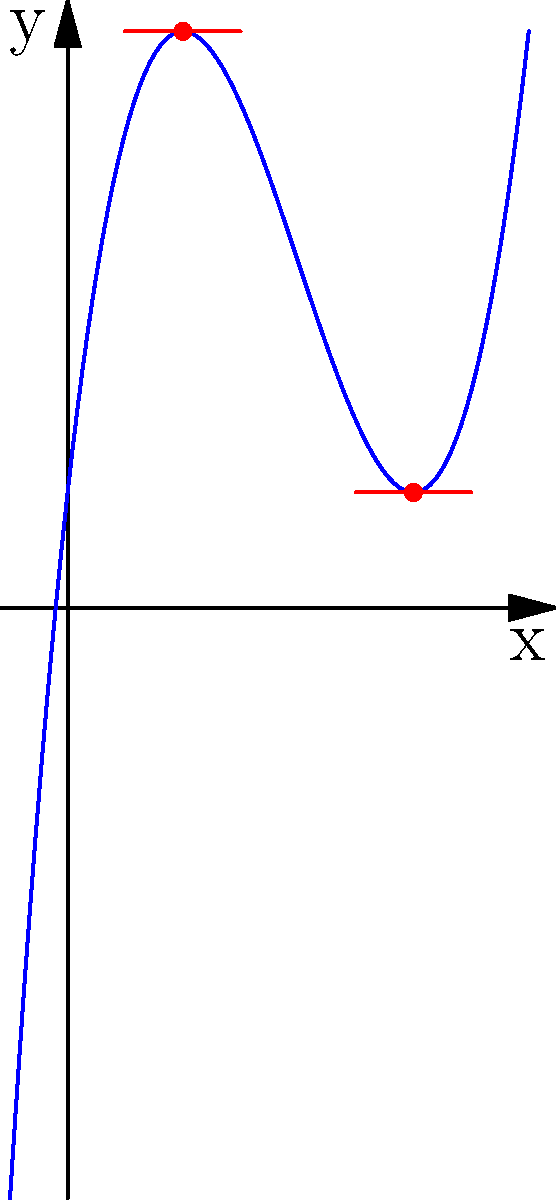Hey Martin, remember when we used to solve calculus problems together? Here's one that reminded me of you:

The graph shows a cubic function $f(x)=x^3-6x^2+9x+1$. Two tangent lines are drawn at $x=1$ and $x=3$. How does the rate of change at these two points compare? Let's approach this step-by-step:

1) The rate of change at a point is given by the derivative of the function at that point.

2) For $f(x)=x^3-6x^2+9x+1$, the derivative is $f'(x)=3x^2-12x+9$.

3) To find the rate of change at $x=1$:
   $f'(1) = 3(1)^2 - 12(1) + 9 = 3 - 12 + 9 = 0$

4) To find the rate of change at $x=3$:
   $f'(3) = 3(3)^2 - 12(3) + 9 = 27 - 36 + 9 = 0$

5) We can see that the rate of change (slope of the tangent line) is the same at both points, equal to 0.

6) This means that both points are stationary points on the curve, where the tangent line is horizontal.

7) Looking at the graph, we can confirm this: both tangent lines appear to be horizontal.
Answer: The rate of change is equal (0) at both points. 